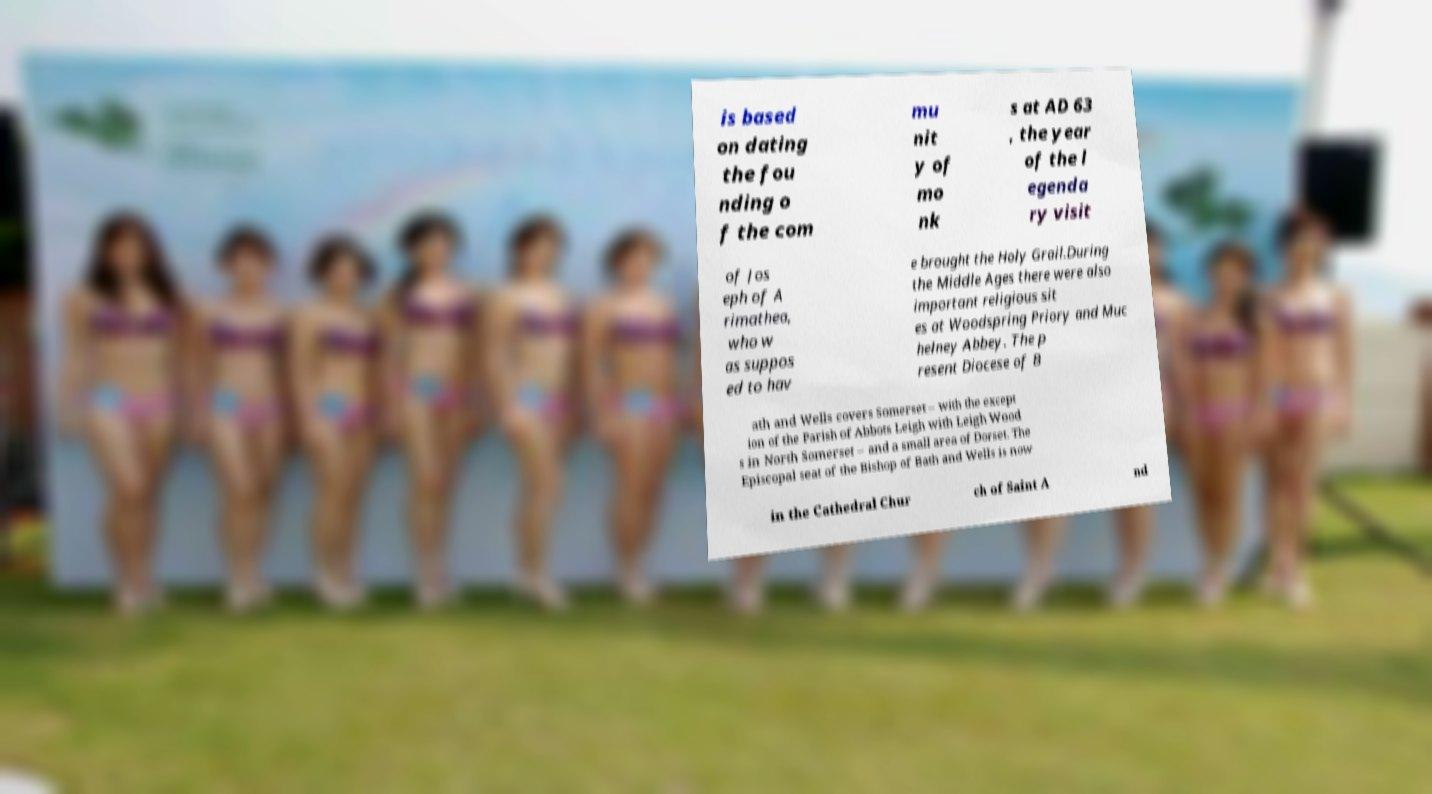Can you accurately transcribe the text from the provided image for me? is based on dating the fou nding o f the com mu nit y of mo nk s at AD 63 , the year of the l egenda ry visit of Jos eph of A rimathea, who w as suppos ed to hav e brought the Holy Grail.During the Middle Ages there were also important religious sit es at Woodspring Priory and Muc helney Abbey. The p resent Diocese of B ath and Wells covers Somerset – with the except ion of the Parish of Abbots Leigh with Leigh Wood s in North Somerset – and a small area of Dorset. The Episcopal seat of the Bishop of Bath and Wells is now in the Cathedral Chur ch of Saint A nd 